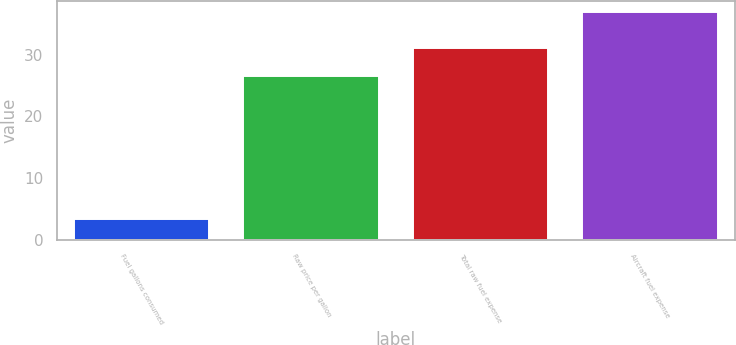Convert chart. <chart><loc_0><loc_0><loc_500><loc_500><bar_chart><fcel>Fuel gallons consumed<fcel>Raw price per gallon<fcel>Total raw fuel expense<fcel>Aircraft fuel expense<nl><fcel>3.4<fcel>26.6<fcel>31<fcel>36.9<nl></chart> 